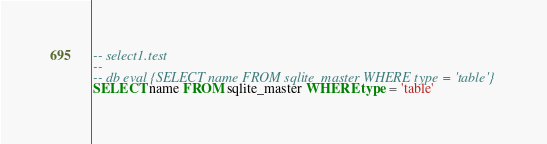<code> <loc_0><loc_0><loc_500><loc_500><_SQL_>-- select1.test
-- 
-- db eval {SELECT name FROM sqlite_master WHERE type = 'table'}
SELECT name FROM sqlite_master WHERE type = 'table'</code> 